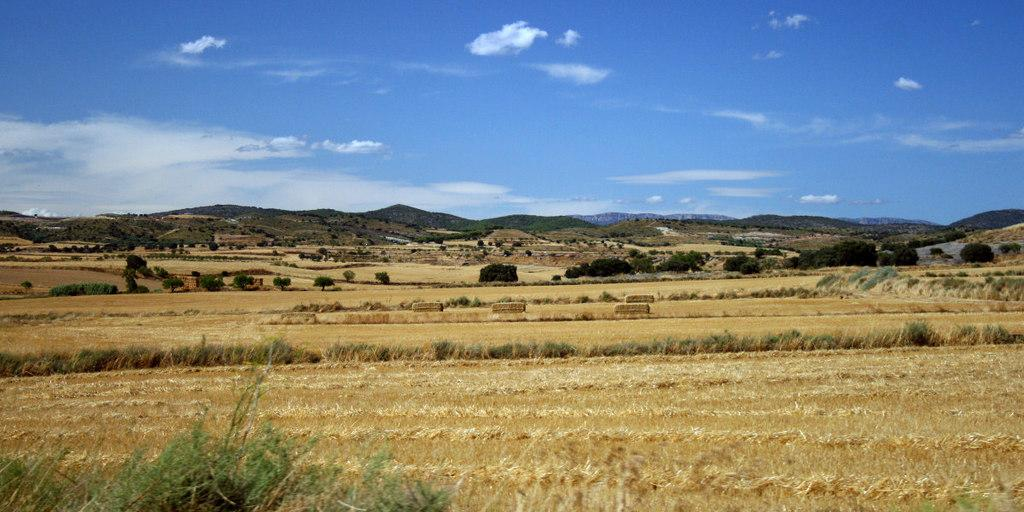What type of living organisms can be seen in the image? Plants can be seen in the image. What color are the plants in the image? The plants are green. What can be seen in the background of the image? There are mountains in the background of the image. What colors are visible in the sky in the image? The sky is blue and white. What type of care is the person in the image providing for their locket? There is no person or locket present in the image; it features plants and a background with mountains. How is the person in the image transporting the plants? There is no person present in the image, so it is not possible to determine how they might be transporting the plants. 